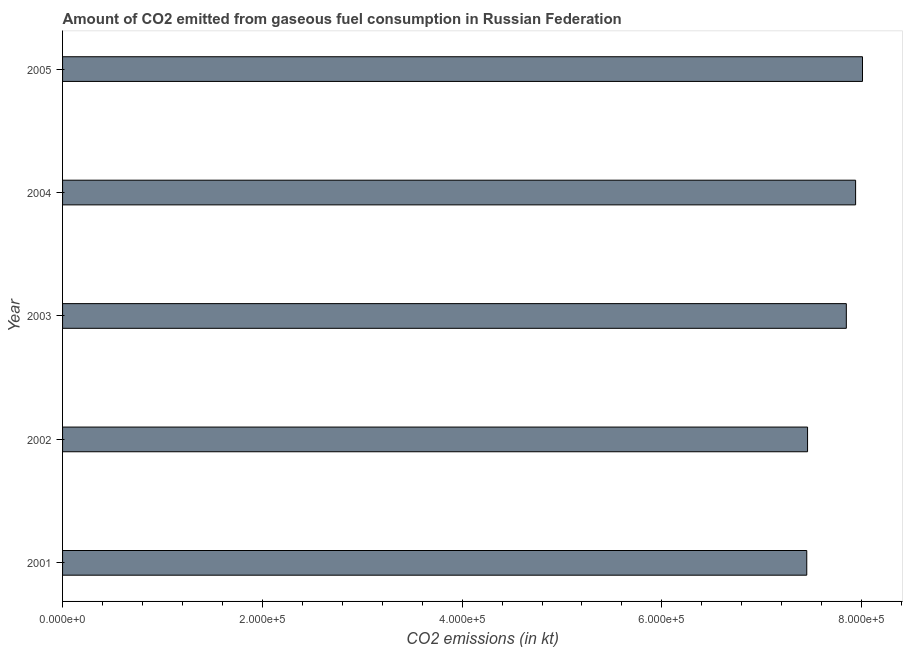Does the graph contain any zero values?
Give a very brief answer. No. Does the graph contain grids?
Give a very brief answer. No. What is the title of the graph?
Keep it short and to the point. Amount of CO2 emitted from gaseous fuel consumption in Russian Federation. What is the label or title of the X-axis?
Provide a short and direct response. CO2 emissions (in kt). What is the co2 emissions from gaseous fuel consumption in 2001?
Ensure brevity in your answer.  7.45e+05. Across all years, what is the maximum co2 emissions from gaseous fuel consumption?
Your answer should be very brief. 8.01e+05. Across all years, what is the minimum co2 emissions from gaseous fuel consumption?
Provide a short and direct response. 7.45e+05. In which year was the co2 emissions from gaseous fuel consumption maximum?
Ensure brevity in your answer.  2005. What is the sum of the co2 emissions from gaseous fuel consumption?
Give a very brief answer. 3.87e+06. What is the difference between the co2 emissions from gaseous fuel consumption in 2002 and 2004?
Offer a very short reply. -4.81e+04. What is the average co2 emissions from gaseous fuel consumption per year?
Your answer should be compact. 7.74e+05. What is the median co2 emissions from gaseous fuel consumption?
Make the answer very short. 7.85e+05. What is the ratio of the co2 emissions from gaseous fuel consumption in 2003 to that in 2004?
Give a very brief answer. 0.99. Is the co2 emissions from gaseous fuel consumption in 2001 less than that in 2002?
Give a very brief answer. Yes. What is the difference between the highest and the second highest co2 emissions from gaseous fuel consumption?
Ensure brevity in your answer.  6890.29. What is the difference between the highest and the lowest co2 emissions from gaseous fuel consumption?
Your answer should be very brief. 5.58e+04. How many bars are there?
Your answer should be compact. 5. Are all the bars in the graph horizontal?
Offer a very short reply. Yes. What is the difference between two consecutive major ticks on the X-axis?
Your response must be concise. 2.00e+05. Are the values on the major ticks of X-axis written in scientific E-notation?
Your response must be concise. Yes. What is the CO2 emissions (in kt) in 2001?
Your answer should be compact. 7.45e+05. What is the CO2 emissions (in kt) of 2002?
Keep it short and to the point. 7.46e+05. What is the CO2 emissions (in kt) in 2003?
Your answer should be compact. 7.85e+05. What is the CO2 emissions (in kt) in 2004?
Your answer should be compact. 7.94e+05. What is the CO2 emissions (in kt) in 2005?
Your response must be concise. 8.01e+05. What is the difference between the CO2 emissions (in kt) in 2001 and 2002?
Give a very brief answer. -799.41. What is the difference between the CO2 emissions (in kt) in 2001 and 2003?
Keep it short and to the point. -3.96e+04. What is the difference between the CO2 emissions (in kt) in 2001 and 2004?
Offer a very short reply. -4.89e+04. What is the difference between the CO2 emissions (in kt) in 2001 and 2005?
Offer a terse response. -5.58e+04. What is the difference between the CO2 emissions (in kt) in 2002 and 2003?
Your response must be concise. -3.88e+04. What is the difference between the CO2 emissions (in kt) in 2002 and 2004?
Your answer should be very brief. -4.81e+04. What is the difference between the CO2 emissions (in kt) in 2002 and 2005?
Your answer should be very brief. -5.50e+04. What is the difference between the CO2 emissions (in kt) in 2003 and 2004?
Make the answer very short. -9299.51. What is the difference between the CO2 emissions (in kt) in 2003 and 2005?
Ensure brevity in your answer.  -1.62e+04. What is the difference between the CO2 emissions (in kt) in 2004 and 2005?
Offer a very short reply. -6890.29. What is the ratio of the CO2 emissions (in kt) in 2001 to that in 2004?
Ensure brevity in your answer.  0.94. What is the ratio of the CO2 emissions (in kt) in 2001 to that in 2005?
Give a very brief answer. 0.93. What is the ratio of the CO2 emissions (in kt) in 2002 to that in 2003?
Make the answer very short. 0.95. What is the ratio of the CO2 emissions (in kt) in 2002 to that in 2004?
Keep it short and to the point. 0.94. What is the ratio of the CO2 emissions (in kt) in 2004 to that in 2005?
Provide a succinct answer. 0.99. 